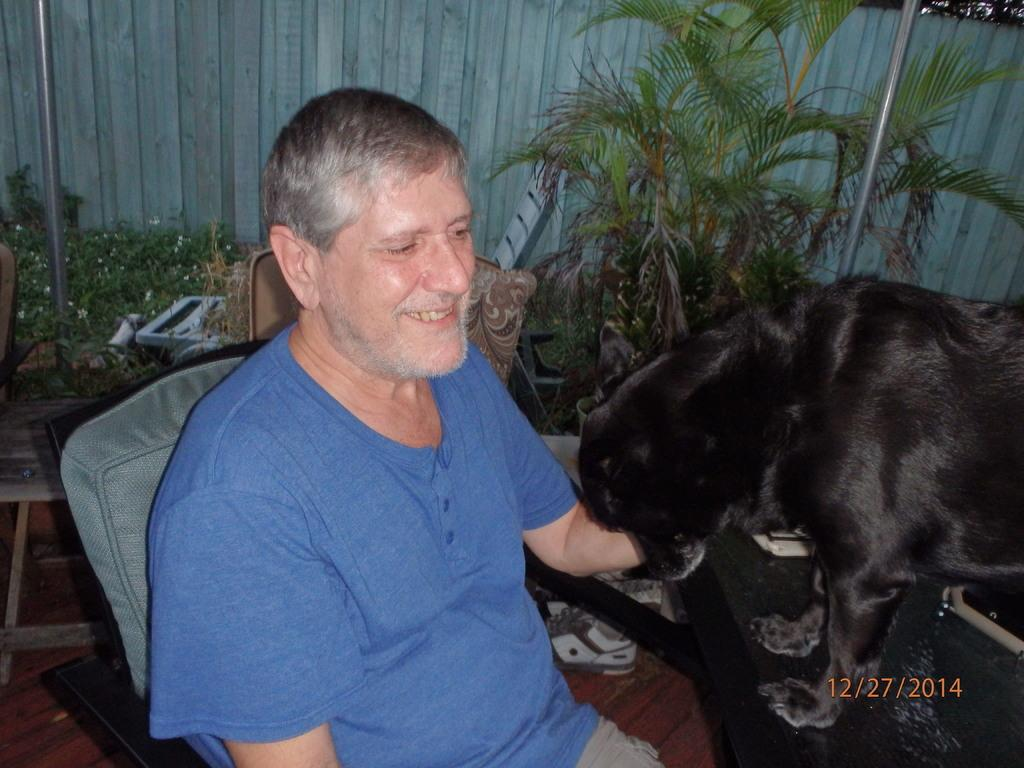Who is present in the image? There is a man in the image. What is the man doing in the image? The man is sitting on a chair in the image. What is the man's facial expression in the image? The man is smiling in the image. What other living creature is present in the image? There is a dog in the image. What can be seen in the background of the image? There are plants in the background of the image. What type of insurance policy does the dog have in the image? There is no mention of insurance or any insurance policy in the image. Additionally, the dog does not have the ability to have an insurance policy. 